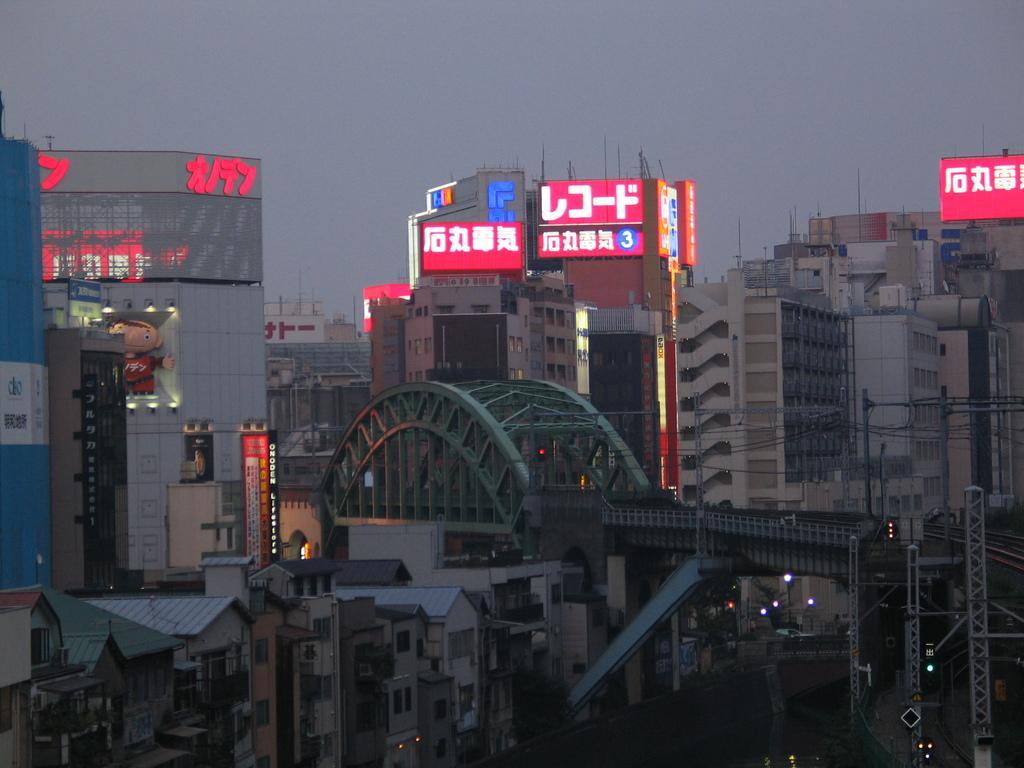Please provide a concise description of this image. In this image I can see number of buildings, number of boards, few light, wires and on these words I can see something is written. 